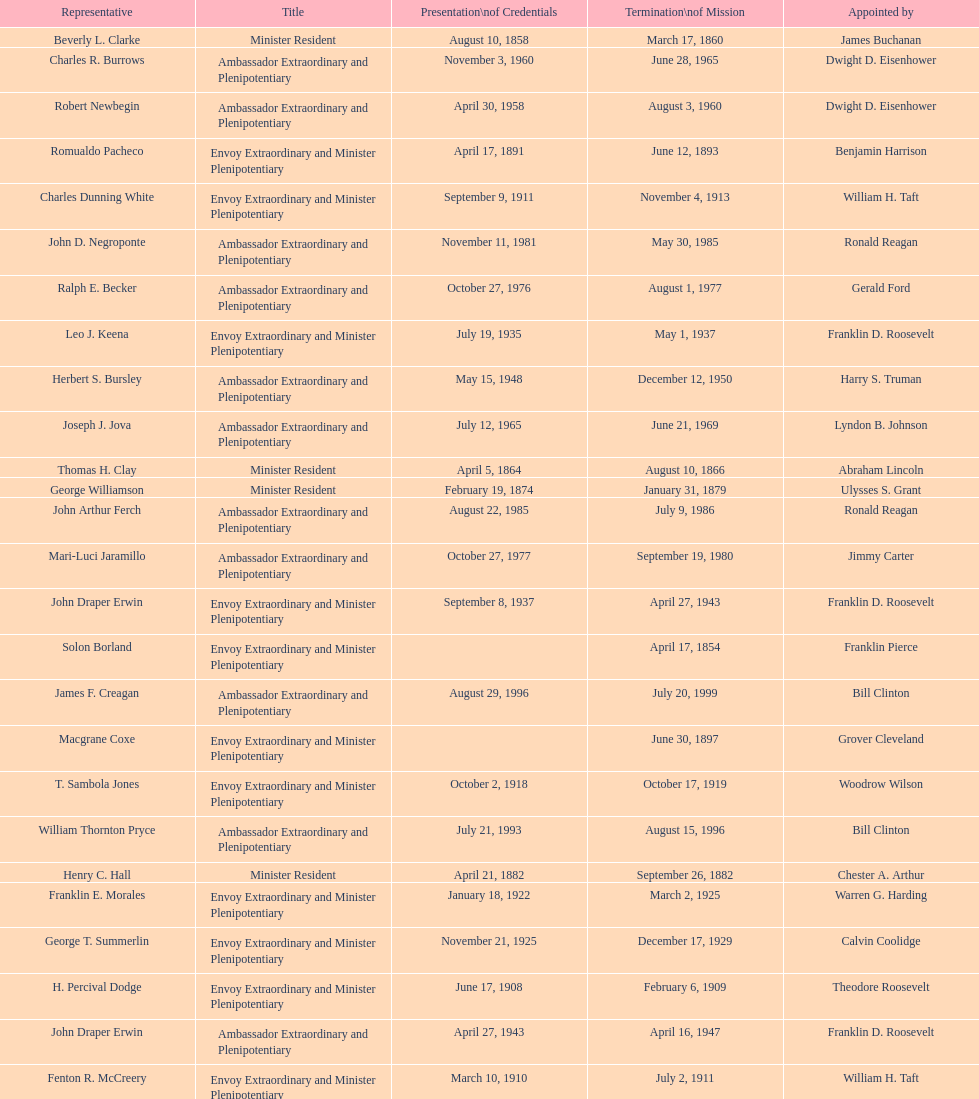Which minister resident had the shortest appointment? Henry C. Hall. 